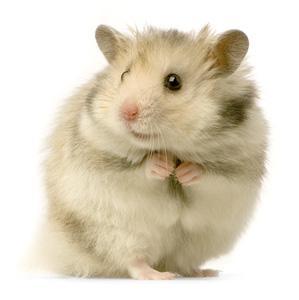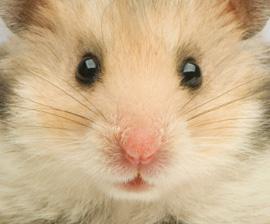The first image is the image on the left, the second image is the image on the right. For the images shown, is this caption "In at least one of the images, the hamster is holding food" true? Answer yes or no. No. 